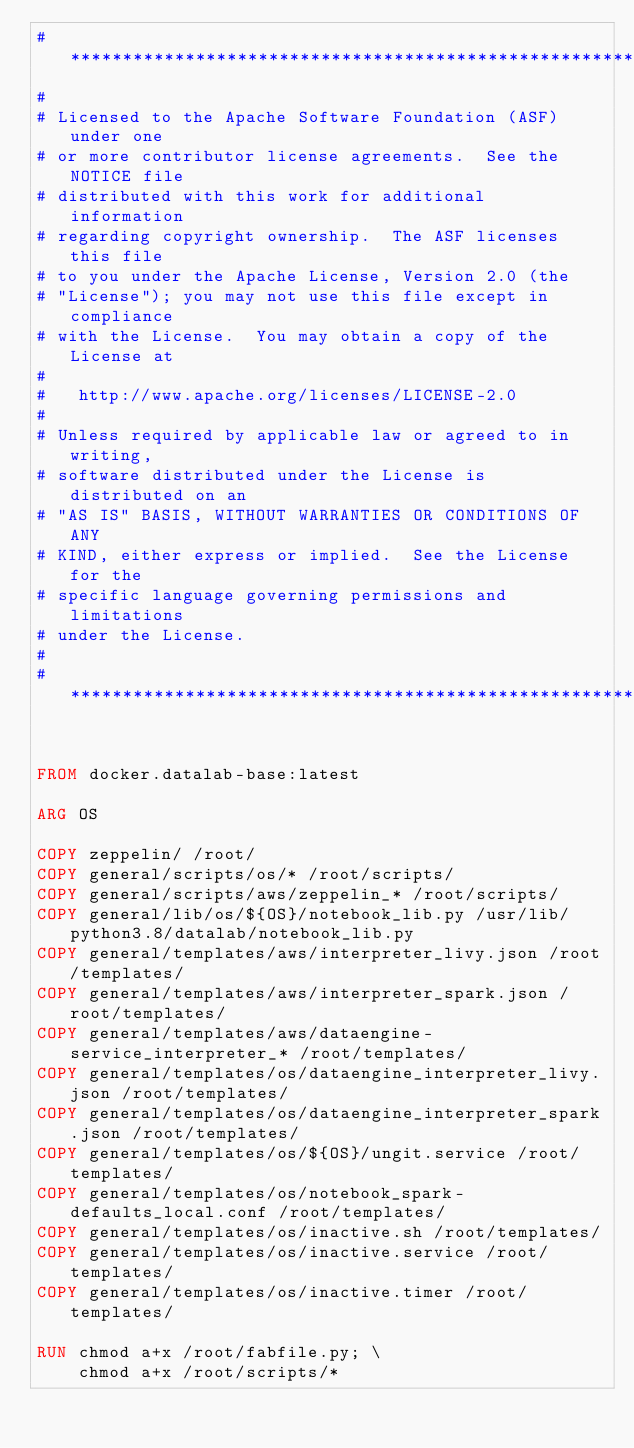Convert code to text. <code><loc_0><loc_0><loc_500><loc_500><_Dockerfile_># *****************************************************************************
#
# Licensed to the Apache Software Foundation (ASF) under one
# or more contributor license agreements.  See the NOTICE file
# distributed with this work for additional information
# regarding copyright ownership.  The ASF licenses this file
# to you under the Apache License, Version 2.0 (the
# "License"); you may not use this file except in compliance
# with the License.  You may obtain a copy of the License at
#
#   http://www.apache.org/licenses/LICENSE-2.0
#
# Unless required by applicable law or agreed to in writing,
# software distributed under the License is distributed on an
# "AS IS" BASIS, WITHOUT WARRANTIES OR CONDITIONS OF ANY
# KIND, either express or implied.  See the License for the
# specific language governing permissions and limitations
# under the License.
#
# ******************************************************************************


FROM docker.datalab-base:latest

ARG OS

COPY zeppelin/ /root/
COPY general/scripts/os/* /root/scripts/
COPY general/scripts/aws/zeppelin_* /root/scripts/
COPY general/lib/os/${OS}/notebook_lib.py /usr/lib/python3.8/datalab/notebook_lib.py
COPY general/templates/aws/interpreter_livy.json /root/templates/
COPY general/templates/aws/interpreter_spark.json /root/templates/
COPY general/templates/aws/dataengine-service_interpreter_* /root/templates/
COPY general/templates/os/dataengine_interpreter_livy.json /root/templates/
COPY general/templates/os/dataengine_interpreter_spark.json /root/templates/
COPY general/templates/os/${OS}/ungit.service /root/templates/
COPY general/templates/os/notebook_spark-defaults_local.conf /root/templates/
COPY general/templates/os/inactive.sh /root/templates/
COPY general/templates/os/inactive.service /root/templates/
COPY general/templates/os/inactive.timer /root/templates/

RUN chmod a+x /root/fabfile.py; \
    chmod a+x /root/scripts/*

</code> 